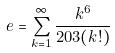<formula> <loc_0><loc_0><loc_500><loc_500>e = \sum _ { k = 1 } ^ { \infty } \frac { k ^ { 6 } } { 2 0 3 ( k ! ) }</formula> 